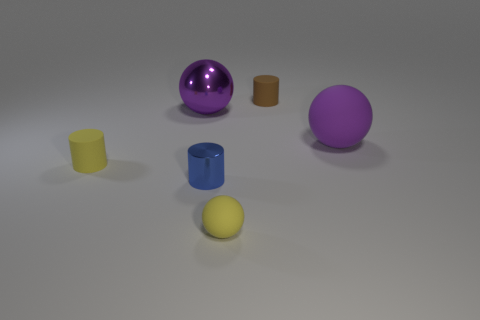There is a small yellow object that is behind the small yellow rubber object that is on the right side of the yellow matte cylinder; is there a big shiny ball behind it?
Offer a very short reply. Yes. Are there fewer big purple metal objects that are in front of the small metal cylinder than shiny things in front of the yellow rubber ball?
Your answer should be compact. No. How many yellow balls have the same material as the tiny yellow cylinder?
Provide a short and direct response. 1. There is a purple metallic sphere; is it the same size as the yellow matte thing on the right side of the metal ball?
Offer a very short reply. No. What material is the small cylinder that is the same color as the small sphere?
Keep it short and to the point. Rubber. How big is the matte ball on the left side of the purple object that is in front of the sphere that is left of the small blue metallic cylinder?
Your answer should be compact. Small. Is the number of tiny rubber objects to the right of the tiny brown object greater than the number of small yellow rubber cylinders behind the metal ball?
Make the answer very short. No. What number of metal objects are left of the cylinder that is on the left side of the tiny shiny thing?
Offer a very short reply. 0. Is there another tiny shiny sphere of the same color as the small ball?
Ensure brevity in your answer.  No. Is the size of the shiny ball the same as the yellow cylinder?
Provide a succinct answer. No. 